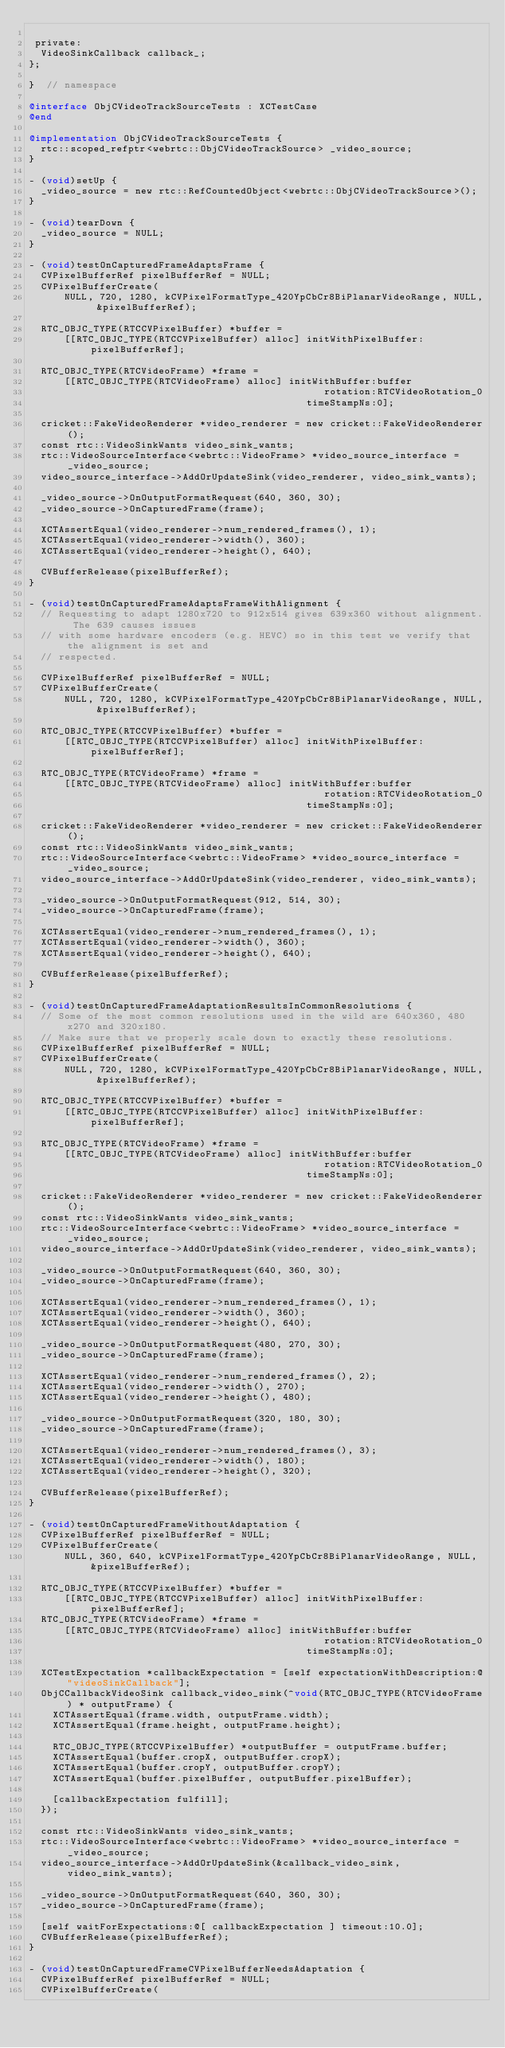Convert code to text. <code><loc_0><loc_0><loc_500><loc_500><_ObjectiveC_>
 private:
  VideoSinkCallback callback_;
};

}  // namespace

@interface ObjCVideoTrackSourceTests : XCTestCase
@end

@implementation ObjCVideoTrackSourceTests {
  rtc::scoped_refptr<webrtc::ObjCVideoTrackSource> _video_source;
}

- (void)setUp {
  _video_source = new rtc::RefCountedObject<webrtc::ObjCVideoTrackSource>();
}

- (void)tearDown {
  _video_source = NULL;
}

- (void)testOnCapturedFrameAdaptsFrame {
  CVPixelBufferRef pixelBufferRef = NULL;
  CVPixelBufferCreate(
      NULL, 720, 1280, kCVPixelFormatType_420YpCbCr8BiPlanarVideoRange, NULL, &pixelBufferRef);

  RTC_OBJC_TYPE(RTCCVPixelBuffer) *buffer =
      [[RTC_OBJC_TYPE(RTCCVPixelBuffer) alloc] initWithPixelBuffer:pixelBufferRef];

  RTC_OBJC_TYPE(RTCVideoFrame) *frame =
      [[RTC_OBJC_TYPE(RTCVideoFrame) alloc] initWithBuffer:buffer
                                                  rotation:RTCVideoRotation_0
                                               timeStampNs:0];

  cricket::FakeVideoRenderer *video_renderer = new cricket::FakeVideoRenderer();
  const rtc::VideoSinkWants video_sink_wants;
  rtc::VideoSourceInterface<webrtc::VideoFrame> *video_source_interface = _video_source;
  video_source_interface->AddOrUpdateSink(video_renderer, video_sink_wants);

  _video_source->OnOutputFormatRequest(640, 360, 30);
  _video_source->OnCapturedFrame(frame);

  XCTAssertEqual(video_renderer->num_rendered_frames(), 1);
  XCTAssertEqual(video_renderer->width(), 360);
  XCTAssertEqual(video_renderer->height(), 640);

  CVBufferRelease(pixelBufferRef);
}

- (void)testOnCapturedFrameAdaptsFrameWithAlignment {
  // Requesting to adapt 1280x720 to 912x514 gives 639x360 without alignment. The 639 causes issues
  // with some hardware encoders (e.g. HEVC) so in this test we verify that the alignment is set and
  // respected.

  CVPixelBufferRef pixelBufferRef = NULL;
  CVPixelBufferCreate(
      NULL, 720, 1280, kCVPixelFormatType_420YpCbCr8BiPlanarVideoRange, NULL, &pixelBufferRef);

  RTC_OBJC_TYPE(RTCCVPixelBuffer) *buffer =
      [[RTC_OBJC_TYPE(RTCCVPixelBuffer) alloc] initWithPixelBuffer:pixelBufferRef];

  RTC_OBJC_TYPE(RTCVideoFrame) *frame =
      [[RTC_OBJC_TYPE(RTCVideoFrame) alloc] initWithBuffer:buffer
                                                  rotation:RTCVideoRotation_0
                                               timeStampNs:0];

  cricket::FakeVideoRenderer *video_renderer = new cricket::FakeVideoRenderer();
  const rtc::VideoSinkWants video_sink_wants;
  rtc::VideoSourceInterface<webrtc::VideoFrame> *video_source_interface = _video_source;
  video_source_interface->AddOrUpdateSink(video_renderer, video_sink_wants);

  _video_source->OnOutputFormatRequest(912, 514, 30);
  _video_source->OnCapturedFrame(frame);

  XCTAssertEqual(video_renderer->num_rendered_frames(), 1);
  XCTAssertEqual(video_renderer->width(), 360);
  XCTAssertEqual(video_renderer->height(), 640);

  CVBufferRelease(pixelBufferRef);
}

- (void)testOnCapturedFrameAdaptationResultsInCommonResolutions {
  // Some of the most common resolutions used in the wild are 640x360, 480x270 and 320x180.
  // Make sure that we properly scale down to exactly these resolutions.
  CVPixelBufferRef pixelBufferRef = NULL;
  CVPixelBufferCreate(
      NULL, 720, 1280, kCVPixelFormatType_420YpCbCr8BiPlanarVideoRange, NULL, &pixelBufferRef);

  RTC_OBJC_TYPE(RTCCVPixelBuffer) *buffer =
      [[RTC_OBJC_TYPE(RTCCVPixelBuffer) alloc] initWithPixelBuffer:pixelBufferRef];

  RTC_OBJC_TYPE(RTCVideoFrame) *frame =
      [[RTC_OBJC_TYPE(RTCVideoFrame) alloc] initWithBuffer:buffer
                                                  rotation:RTCVideoRotation_0
                                               timeStampNs:0];

  cricket::FakeVideoRenderer *video_renderer = new cricket::FakeVideoRenderer();
  const rtc::VideoSinkWants video_sink_wants;
  rtc::VideoSourceInterface<webrtc::VideoFrame> *video_source_interface = _video_source;
  video_source_interface->AddOrUpdateSink(video_renderer, video_sink_wants);

  _video_source->OnOutputFormatRequest(640, 360, 30);
  _video_source->OnCapturedFrame(frame);

  XCTAssertEqual(video_renderer->num_rendered_frames(), 1);
  XCTAssertEqual(video_renderer->width(), 360);
  XCTAssertEqual(video_renderer->height(), 640);

  _video_source->OnOutputFormatRequest(480, 270, 30);
  _video_source->OnCapturedFrame(frame);

  XCTAssertEqual(video_renderer->num_rendered_frames(), 2);
  XCTAssertEqual(video_renderer->width(), 270);
  XCTAssertEqual(video_renderer->height(), 480);

  _video_source->OnOutputFormatRequest(320, 180, 30);
  _video_source->OnCapturedFrame(frame);

  XCTAssertEqual(video_renderer->num_rendered_frames(), 3);
  XCTAssertEqual(video_renderer->width(), 180);
  XCTAssertEqual(video_renderer->height(), 320);

  CVBufferRelease(pixelBufferRef);
}

- (void)testOnCapturedFrameWithoutAdaptation {
  CVPixelBufferRef pixelBufferRef = NULL;
  CVPixelBufferCreate(
      NULL, 360, 640, kCVPixelFormatType_420YpCbCr8BiPlanarVideoRange, NULL, &pixelBufferRef);

  RTC_OBJC_TYPE(RTCCVPixelBuffer) *buffer =
      [[RTC_OBJC_TYPE(RTCCVPixelBuffer) alloc] initWithPixelBuffer:pixelBufferRef];
  RTC_OBJC_TYPE(RTCVideoFrame) *frame =
      [[RTC_OBJC_TYPE(RTCVideoFrame) alloc] initWithBuffer:buffer
                                                  rotation:RTCVideoRotation_0
                                               timeStampNs:0];

  XCTestExpectation *callbackExpectation = [self expectationWithDescription:@"videoSinkCallback"];
  ObjCCallbackVideoSink callback_video_sink(^void(RTC_OBJC_TYPE(RTCVideoFrame) * outputFrame) {
    XCTAssertEqual(frame.width, outputFrame.width);
    XCTAssertEqual(frame.height, outputFrame.height);

    RTC_OBJC_TYPE(RTCCVPixelBuffer) *outputBuffer = outputFrame.buffer;
    XCTAssertEqual(buffer.cropX, outputBuffer.cropX);
    XCTAssertEqual(buffer.cropY, outputBuffer.cropY);
    XCTAssertEqual(buffer.pixelBuffer, outputBuffer.pixelBuffer);

    [callbackExpectation fulfill];
  });

  const rtc::VideoSinkWants video_sink_wants;
  rtc::VideoSourceInterface<webrtc::VideoFrame> *video_source_interface = _video_source;
  video_source_interface->AddOrUpdateSink(&callback_video_sink, video_sink_wants);

  _video_source->OnOutputFormatRequest(640, 360, 30);
  _video_source->OnCapturedFrame(frame);

  [self waitForExpectations:@[ callbackExpectation ] timeout:10.0];
  CVBufferRelease(pixelBufferRef);
}

- (void)testOnCapturedFrameCVPixelBufferNeedsAdaptation {
  CVPixelBufferRef pixelBufferRef = NULL;
  CVPixelBufferCreate(</code> 